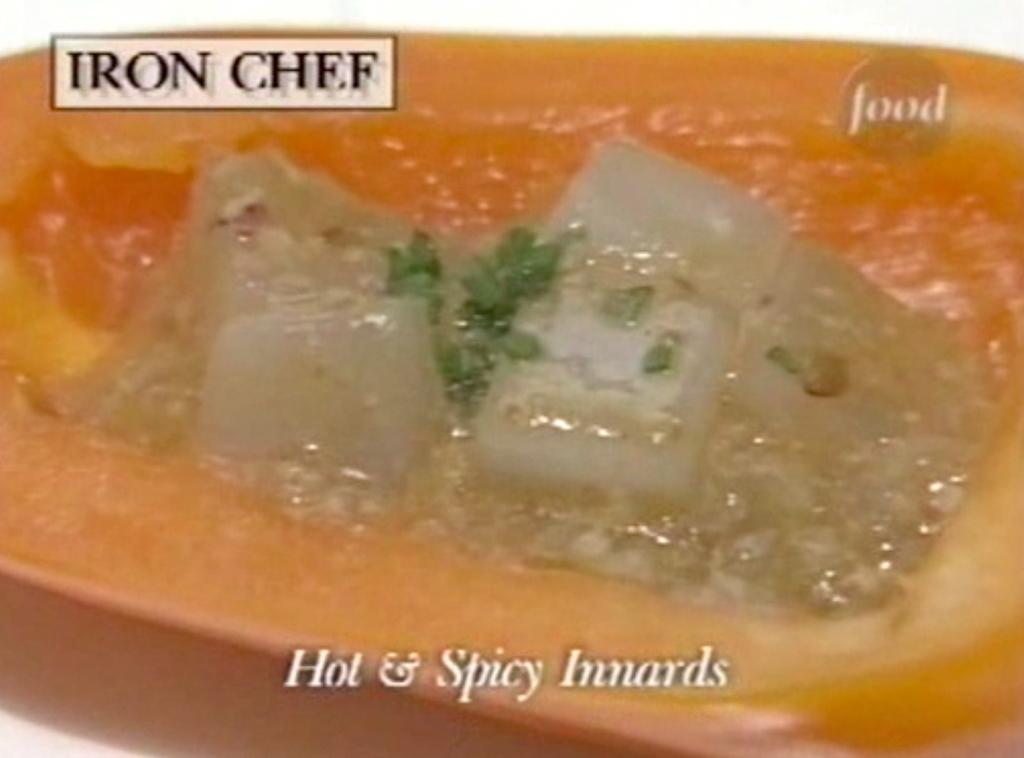What is the main subject of the image? The main subject of the image is food. How is the food arranged or presented in the image? The food is in a tray. Are there any words or letters visible in the image? Yes, there is text visible in the image. What type of chess move is depicted in the image? There is no chess move present in the image; it features food in a tray with visible text. How many sisters are shown interacting with the food in the image? There are no sisters present in the image; it only features food in a tray with visible text. 